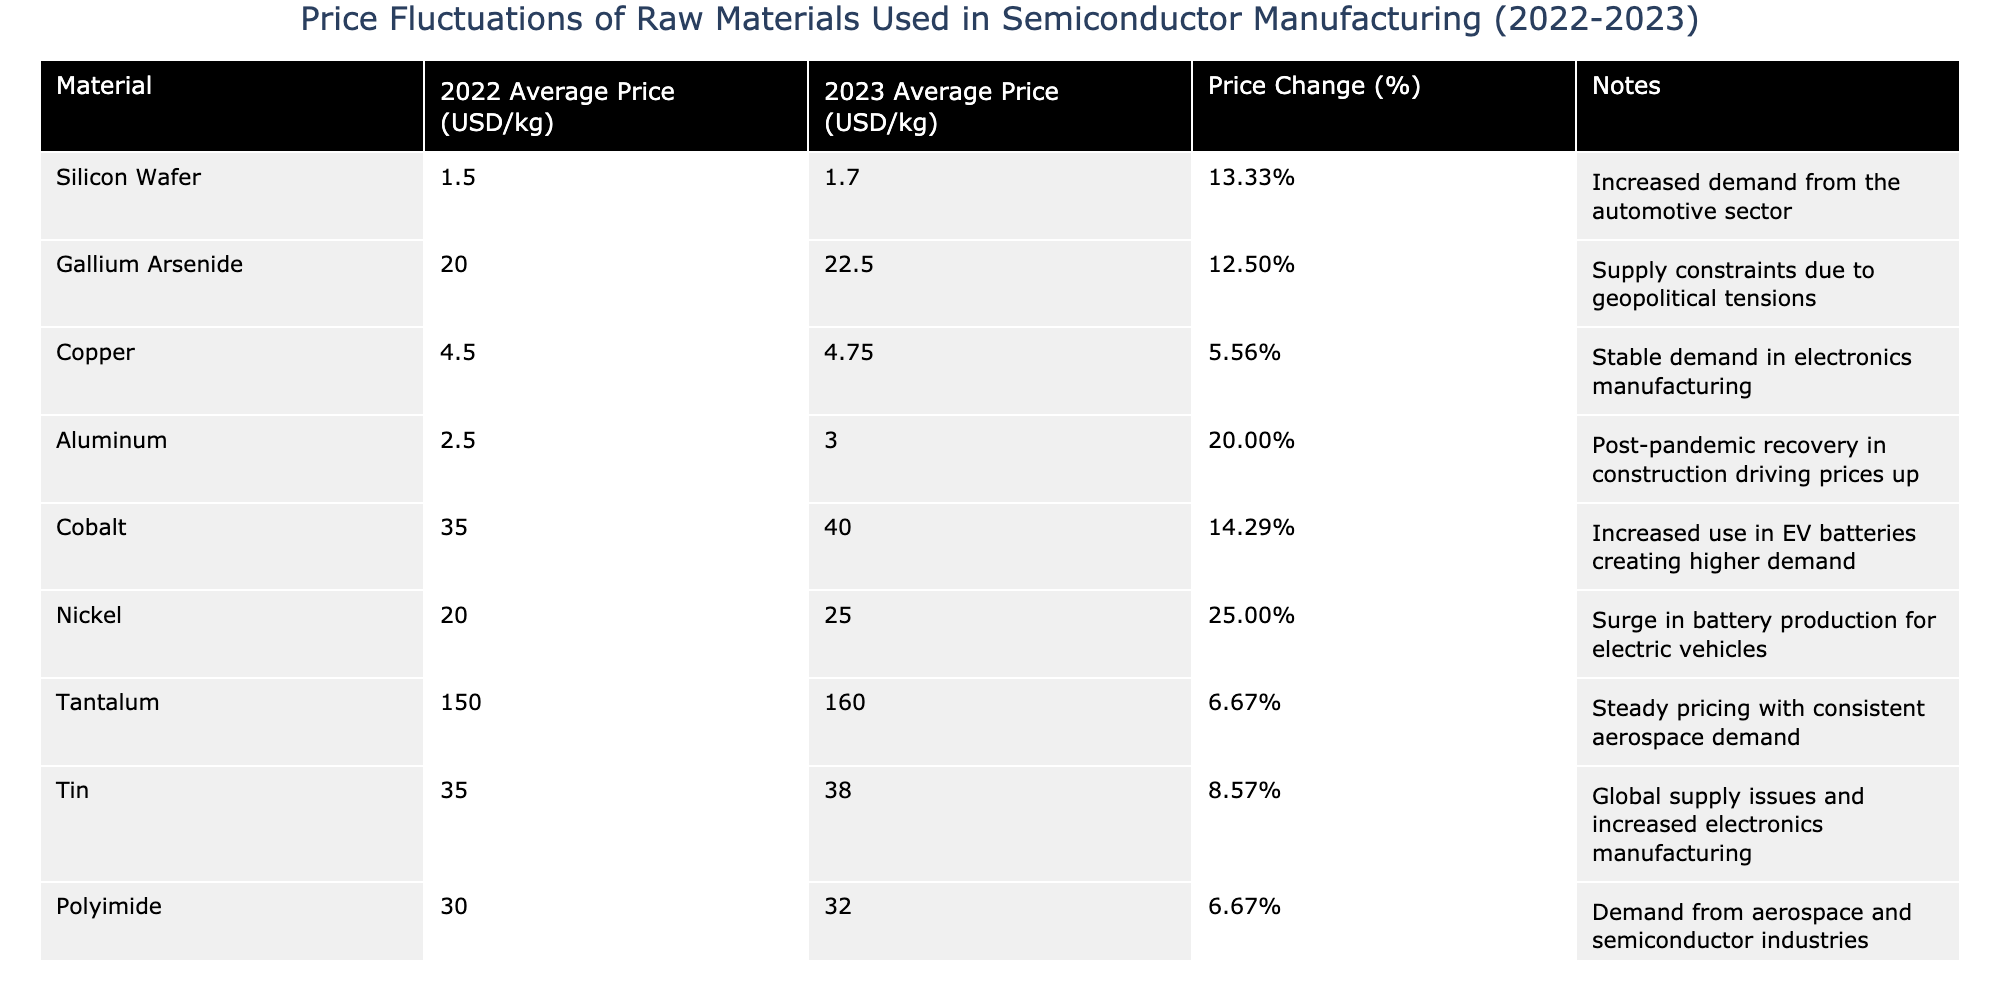What was the average price of Silicon Wafer in 2022? The average price of Silicon Wafer in 2022 is directly listed in the table as 1.50 USD/kg.
Answer: 1.50 USD/kg Which material experienced the highest price increase in percentage terms? By reviewing the 'Price Change (%)' column, Nickel shows a price increase of 25.00%, which is the highest among all materials listed.
Answer: Nickel What was the 2023 average price of Tantalum? The table specifies that the average price of Tantalum in 2023 is 160.00 USD/kg.
Answer: 160.00 USD/kg Is the price of Copper in 2023 higher than in 2022? The 2023 price of Copper is 4.75 USD/kg and the 2022 price is 4.50 USD/kg, thus Copper's price increased from 2022 to 2023.
Answer: Yes What is the total price increase for Cobalt from 2022 to 2023? Cobalt's price increased from 35.00 USD/kg in 2022 to 40.00 USD/kg in 2023. The difference is calculated as 40.00 - 35.00 = 5.00 USD/kg.
Answer: 5.00 USD/kg What is the average price change percentage across all materials listed? The price change percentages are 13.33%, 12.50%, 5.56%, 20.00%, 14.29%, 25.00%, 6.67%, 8.57%, 6.67%, and 10.00%. Summing them gives 118.12%, and dividing by 10 materials gives an average change of 11.81%.
Answer: 11.81% Which materials have a price increase of more than 10%? By examining the 'Price Change (%)' column, it can be seen that Silicon Wafer, Gallium Arsenide, Aluminum, Cobalt, Nickel, Sapphire Substrate all have price increases greater than 10%.
Answer: Silicon Wafer, Gallium Arsenide, Aluminum, Cobalt, Nickel, Sapphire Substrate Was there a price increase for any material that is a key component in batteries? Nickel and Cobalt are essential components in batteries. Both materials had price increases, with Nickel increasing by 25.00% and Cobalt by 14.29%.
Answer: Yes What is the difference in average price between Aluminum in 2022 and Nickel in 2023? Aluminum's 2022 price is 2.50 USD/kg and Nickel's 2023 price is 25.00 USD/kg. The difference is 25.00 - 2.50 = 22.50 USD/kg.
Answer: 22.50 USD/kg Which material has the lowest price in 2022? By checking the 2022 prices listed, Aluminum is priced at 2.50 USD/kg, which is the lowest among the materials.
Answer: Aluminum 